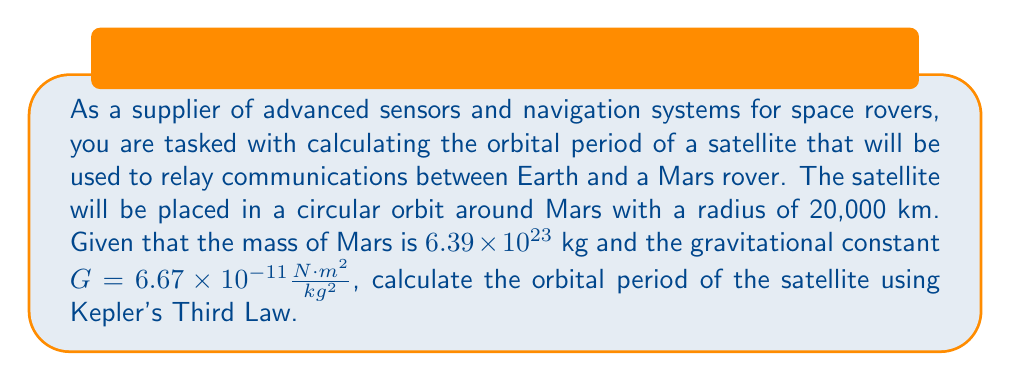Provide a solution to this math problem. To solve this problem, we'll use Kepler's Third Law of Planetary Motion, which states that the square of the orbital period of a planet is directly proportional to the cube of the semi-major axis of its orbit.

For a circular orbit, the semi-major axis is equal to the radius of the orbit. We can express Kepler's Third Law mathematically as:

$$T^2 = \frac{4\pi^2}{GM}r^3$$

Where:
$T$ = orbital period (in seconds)
$G$ = gravitational constant $(6.67 \times 10^{-11} \frac{N \cdot m^2}{kg^2})$
$M$ = mass of the central body (Mars in this case)
$r$ = radius of the orbit

Let's substitute the given values:

$G = 6.67 \times 10^{-11} \frac{N \cdot m^2}{kg^2}$
$M = 6.39 \times 10^{23}$ kg
$r = 20,000,000$ m (converted from 20,000 km)

Now, let's solve for $T$:

$$T^2 = \frac{4\pi^2}{(6.67 \times 10^{-11})(6.39 \times 10^{23})}(20,000,000)^3$$

$$T^2 = \frac{4\pi^2}{4.26213 \times 10^{13}}(8 \times 10^{21})$$

$$T^2 = 7.40477 \times 10^9$$

$$T = \sqrt{7.40477 \times 10^9}$$

$$T = 86,050.9$ seconds

To convert this to hours, we divide by 3600 (the number of seconds in an hour):

$$T = \frac{86,050.9}{3600} = 23.9030$ hours
Answer: The orbital period of the satellite is approximately 23.90 hours. 